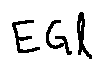<formula> <loc_0><loc_0><loc_500><loc_500>E G l</formula> 